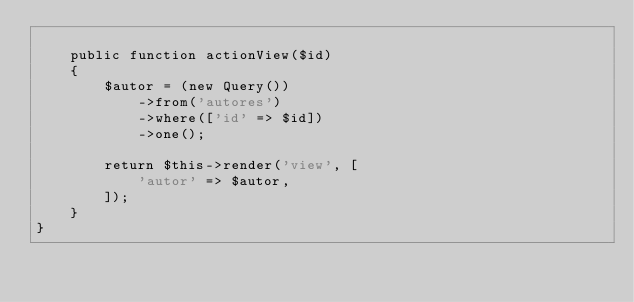Convert code to text. <code><loc_0><loc_0><loc_500><loc_500><_PHP_>
    public function actionView($id)
    {
        $autor = (new Query())
            ->from('autores')
            ->where(['id' => $id])
            ->one();
    
        return $this->render('view', [
            'autor' => $autor,
        ]);
    }    
}</code> 